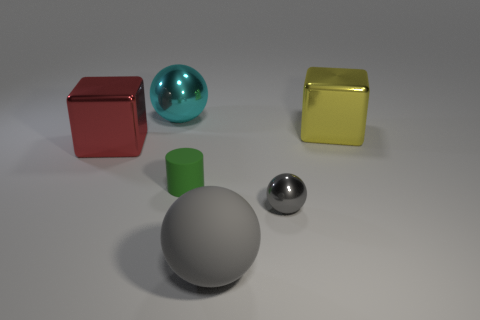Add 3 rubber spheres. How many objects exist? 9 Subtract all cylinders. How many objects are left? 5 Subtract 1 red blocks. How many objects are left? 5 Subtract all green rubber cylinders. Subtract all big red shiny things. How many objects are left? 4 Add 2 large matte things. How many large matte things are left? 3 Add 3 large cyan things. How many large cyan things exist? 4 